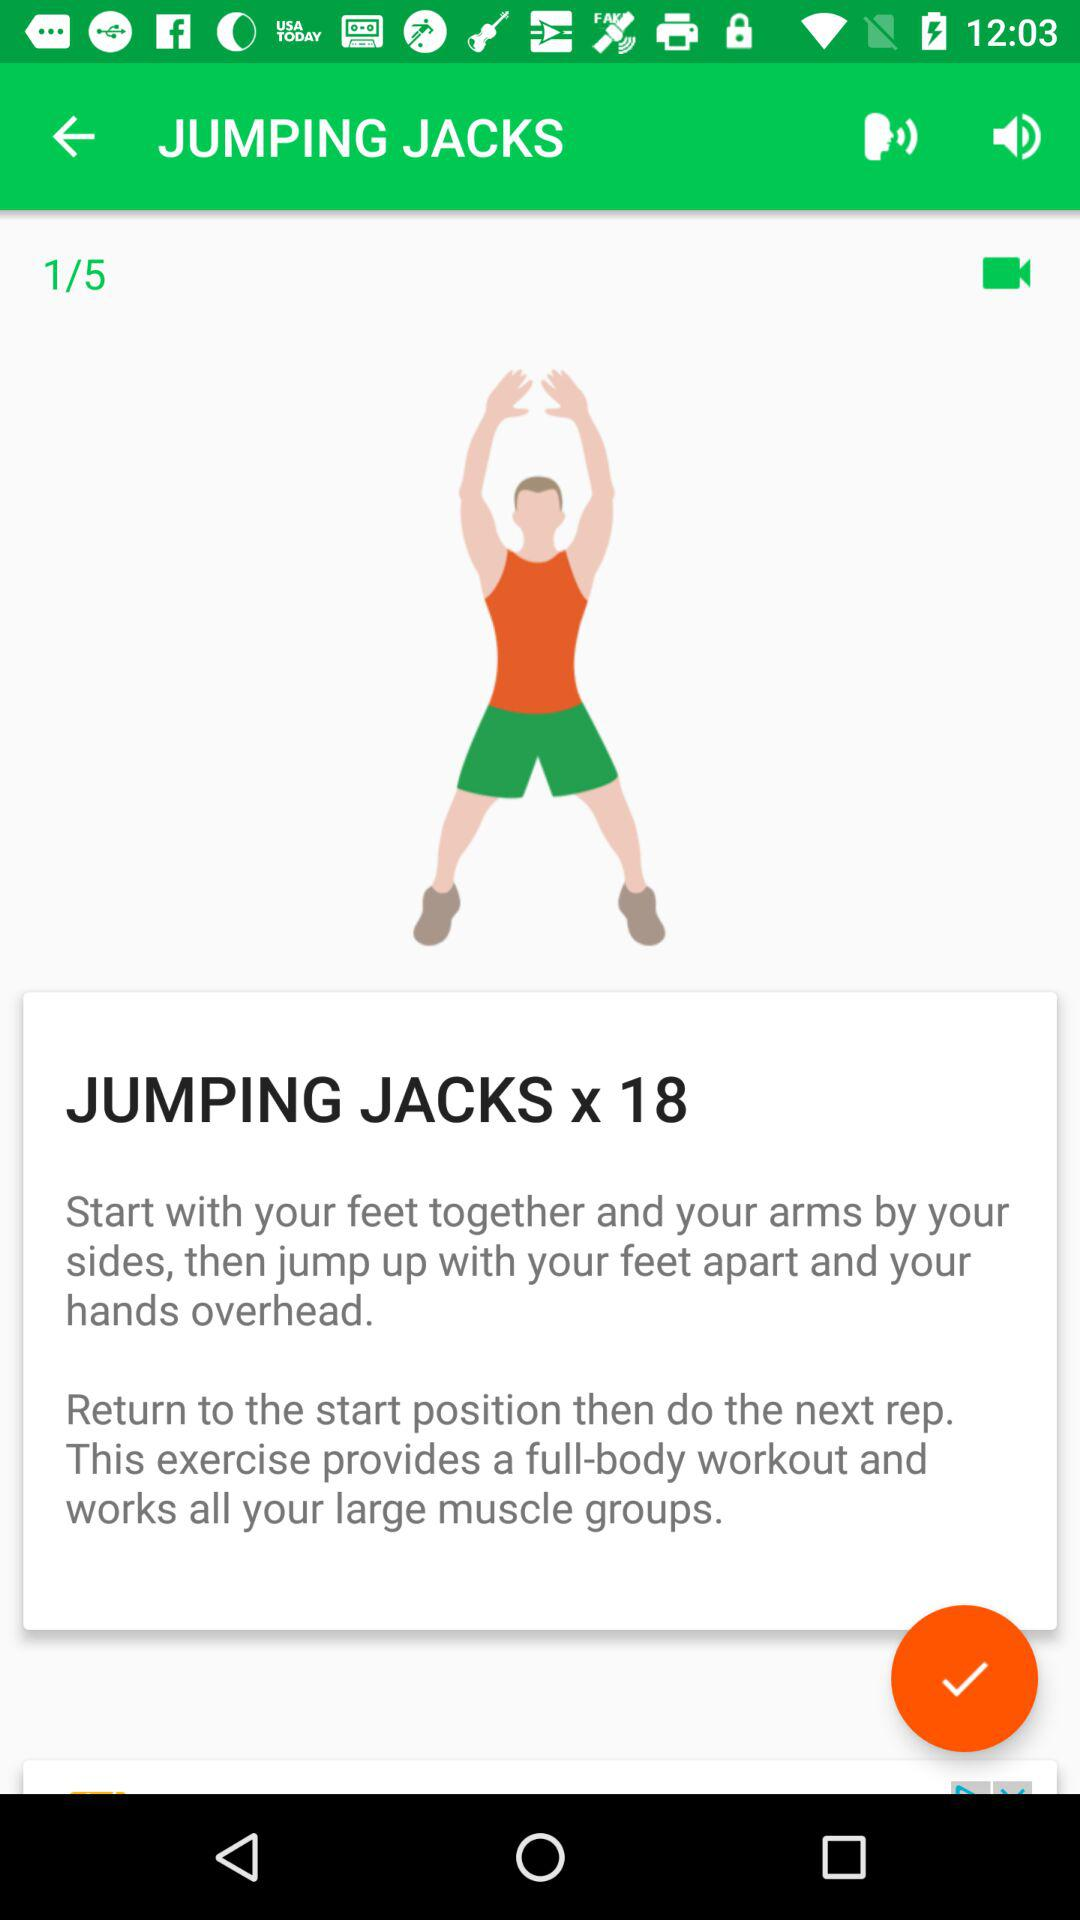How many repetitions of jumping jacks are there?
Answer the question using a single word or phrase. 18 